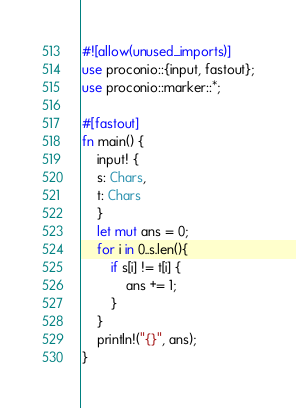Convert code to text. <code><loc_0><loc_0><loc_500><loc_500><_Rust_>#![allow(unused_imports)]
use proconio::{input, fastout};
use proconio::marker::*;

#[fastout]
fn main() {
    input! {
    s: Chars,
    t: Chars
    }
    let mut ans = 0;
    for i in 0..s.len(){
        if s[i] != t[i] {
            ans += 1;
        }
    }
    println!("{}", ans);
}
</code> 